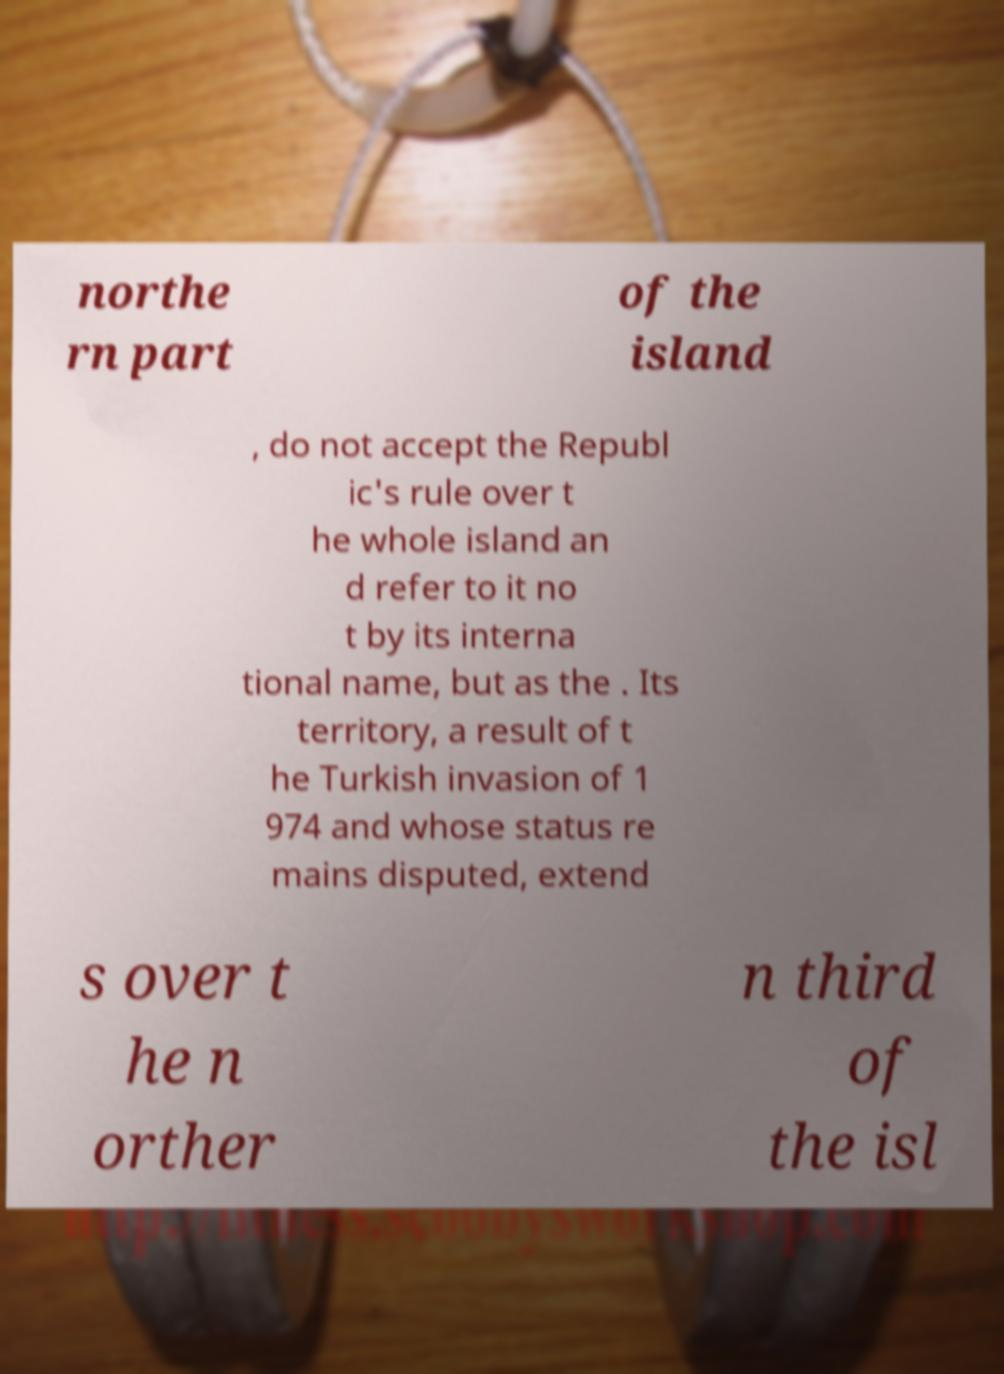Could you extract and type out the text from this image? northe rn part of the island , do not accept the Republ ic's rule over t he whole island an d refer to it no t by its interna tional name, but as the . Its territory, a result of t he Turkish invasion of 1 974 and whose status re mains disputed, extend s over t he n orther n third of the isl 